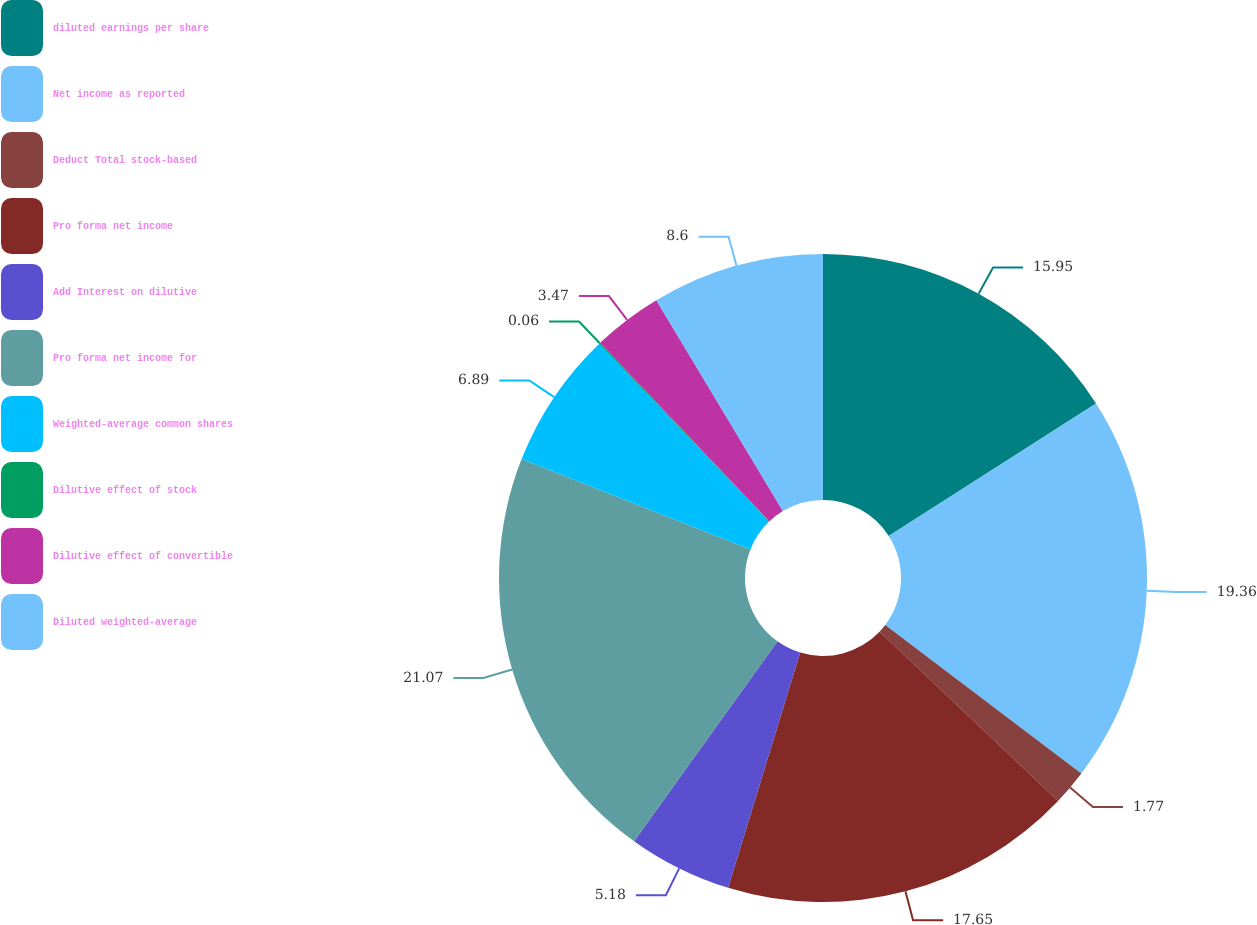Convert chart. <chart><loc_0><loc_0><loc_500><loc_500><pie_chart><fcel>diluted earnings per share<fcel>Net income as reported<fcel>Deduct Total stock-based<fcel>Pro forma net income<fcel>Add Interest on dilutive<fcel>Pro forma net income for<fcel>Weighted-average common shares<fcel>Dilutive effect of stock<fcel>Dilutive effect of convertible<fcel>Diluted weighted-average<nl><fcel>15.95%<fcel>19.36%<fcel>1.77%<fcel>17.65%<fcel>5.18%<fcel>21.07%<fcel>6.89%<fcel>0.06%<fcel>3.47%<fcel>8.6%<nl></chart> 